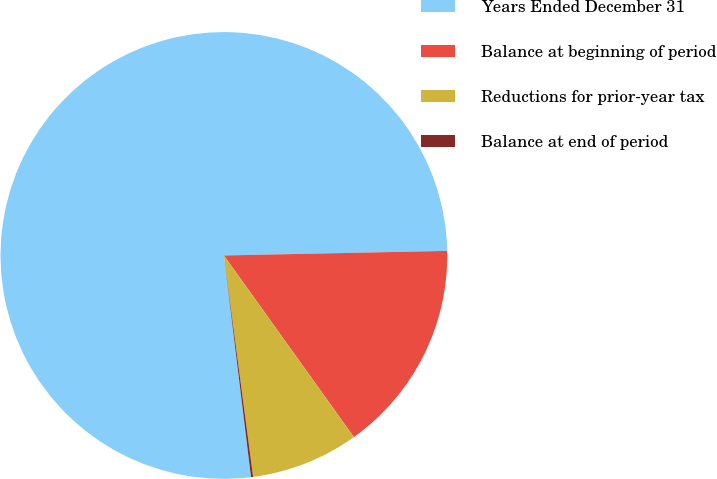Convert chart. <chart><loc_0><loc_0><loc_500><loc_500><pie_chart><fcel>Years Ended December 31<fcel>Balance at beginning of period<fcel>Reductions for prior-year tax<fcel>Balance at end of period<nl><fcel>76.61%<fcel>15.44%<fcel>7.8%<fcel>0.15%<nl></chart> 